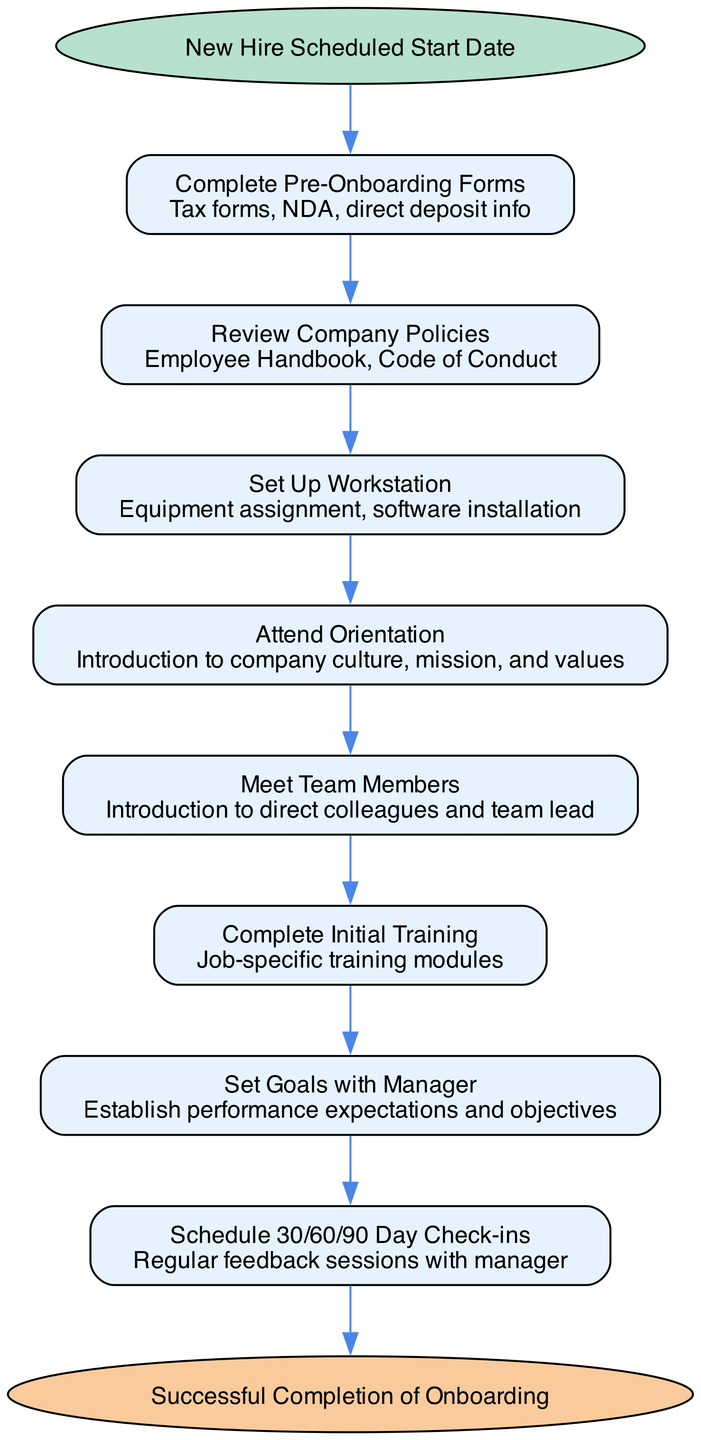What is the first step in the onboarding process? The first step indicated in the diagram is "Complete Pre-Onboarding Forms". This is derived from the sequence starting from the "Start" node, which lists the initial action required.
Answer: Complete Pre-Onboarding Forms How many steps are there in the onboarding checklist? By counting the individual steps in the diagram, there are a total of 8 steps listed before reaching the end of the onboarding process.
Answer: 8 What comes after "Attend Orientation"? The step that follows "Attend Orientation" is "Meet Team Members". This is noted in the flow where each step leads to the next.
Answer: Meet Team Members What is the final outcome of the onboarding process? The diagram specifies that the onboarding process ends with "Successful Completion of Onboarding". This is positioned at the end of the flowchart.
Answer: Successful Completion of Onboarding Which step involves establishing performance expectations? The step that focuses on establishing performance expectations is "Set Goals with Manager". This step is directly mentioned in the flow sequence.
Answer: Set Goals with Manager What type of training is completed before scheduling check-ins? Before scheduling check-ins, the onboarding process requires completing "Initial Training". This is part of the sequential flow leading to setting goals.
Answer: Initial Training How many feedback sessions are scheduled with the manager? The diagram indicates "Schedule 30/60/90 Day Check-ins", suggesting that there are three planned feedback sessions throughout the onboarding timeline.
Answer: 30/60/90 Day Check-ins What does the step "Review Company Policies" entail? The step "Review Company Policies" involves reviewing the "Employee Handbook" and "Code of Conduct", which are detailed in the description for that step.
Answer: Employee Handbook, Code of Conduct What color represents the start node in the diagram? The start node is represented by the color "#B7E1CD". This color is specified in the settings for the node styling in the graph.
Answer: #B7E1CD 